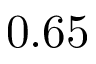<formula> <loc_0><loc_0><loc_500><loc_500>0 . 6 5</formula> 